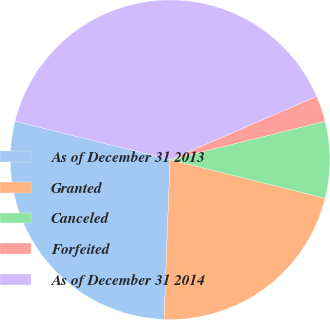<chart> <loc_0><loc_0><loc_500><loc_500><pie_chart><fcel>As of December 31 2013<fcel>Granted<fcel>Canceled<fcel>Forfeited<fcel>As of December 31 2014<nl><fcel>28.28%<fcel>21.72%<fcel>7.75%<fcel>2.62%<fcel>39.62%<nl></chart> 